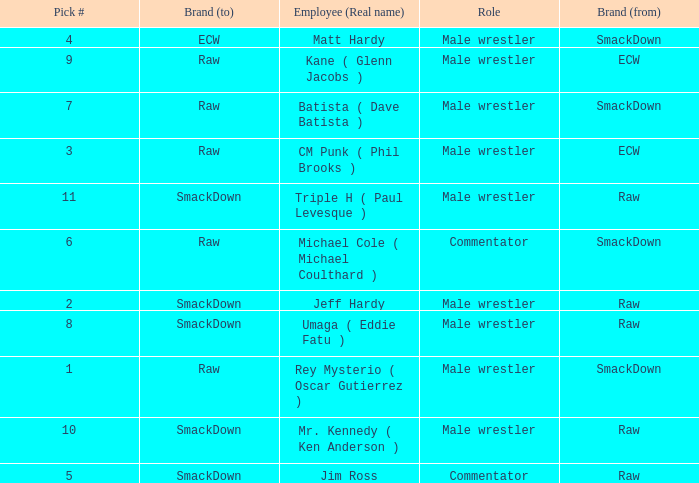What is the real name of the Pick # that is greater than 9? Mr. Kennedy ( Ken Anderson ), Triple H ( Paul Levesque ). 